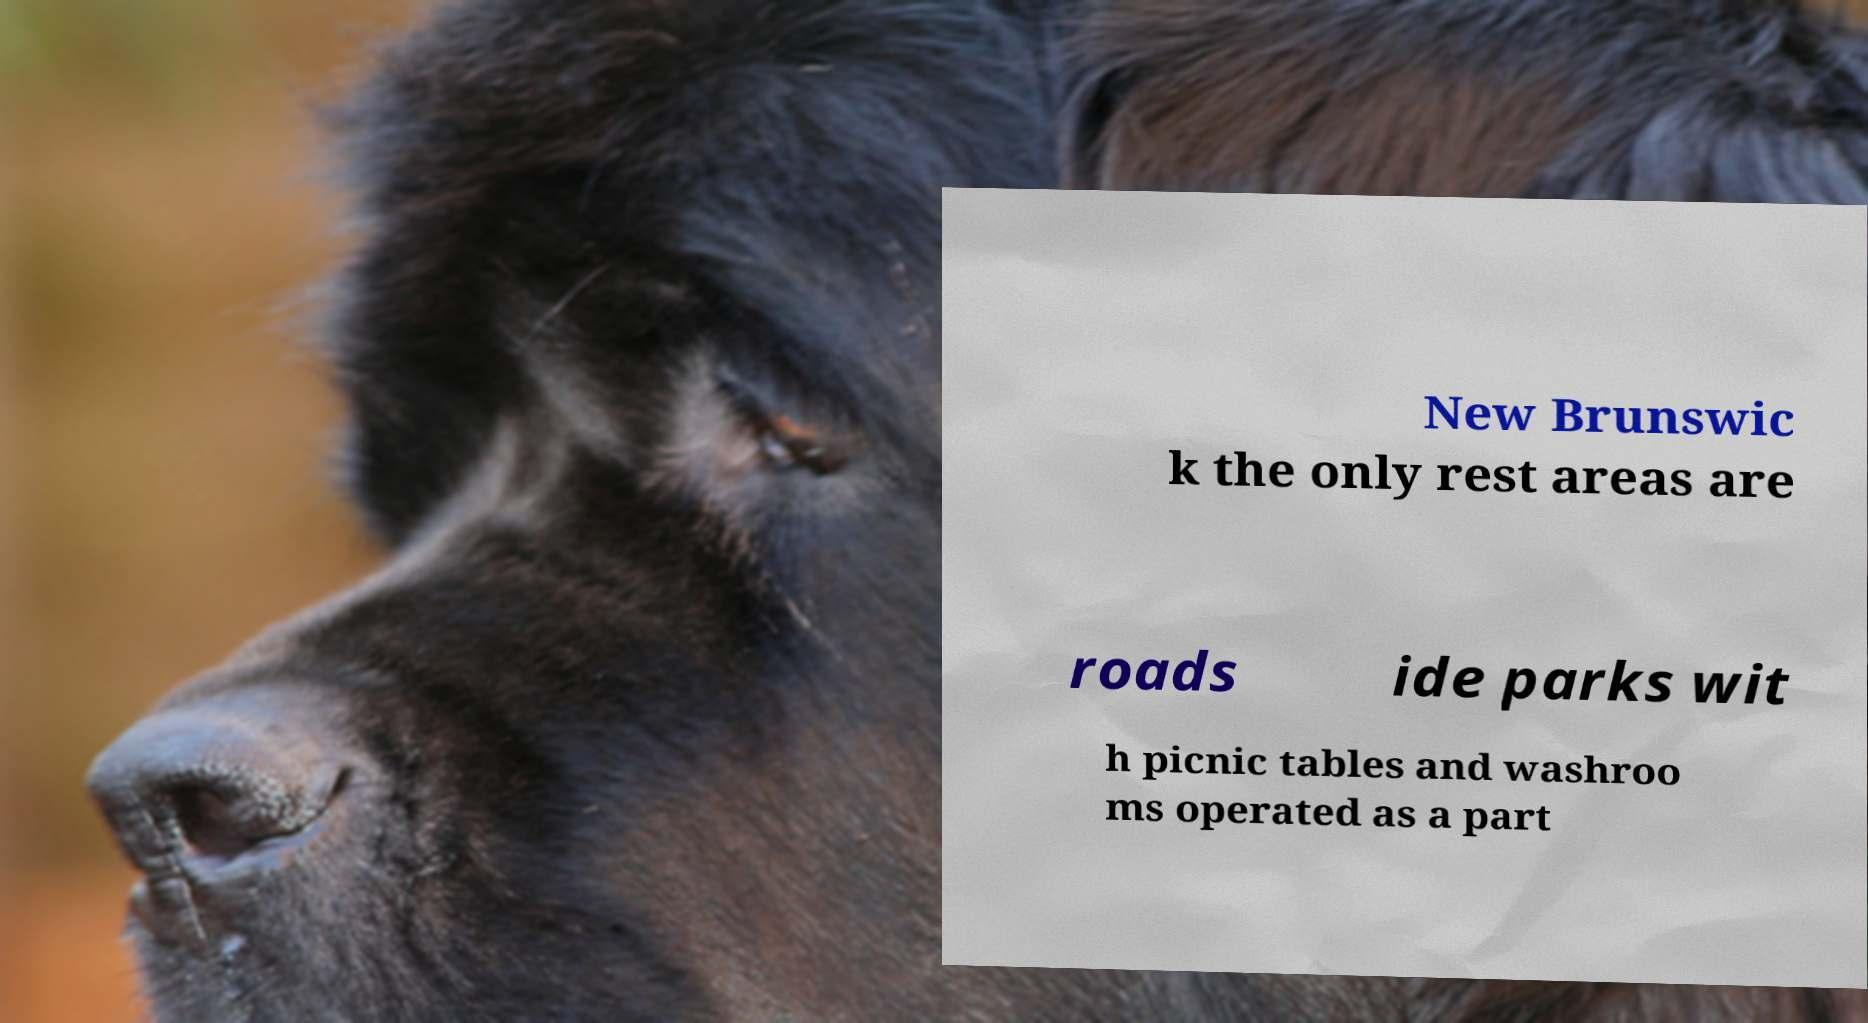Could you extract and type out the text from this image? New Brunswic k the only rest areas are roads ide parks wit h picnic tables and washroo ms operated as a part 